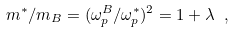<formula> <loc_0><loc_0><loc_500><loc_500>m ^ { * } / m _ { B } = ( \omega _ { p } ^ { B } / \omega _ { p } ^ { * } ) ^ { 2 } = 1 + \lambda \ ,</formula> 